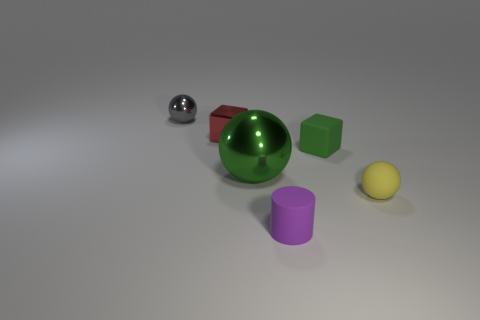Is there a tiny cube made of the same material as the large sphere?
Your answer should be compact. Yes. The block that is behind the matte thing behind the big green ball is made of what material?
Your answer should be compact. Metal. Are there an equal number of big green metal balls that are on the left side of the green metallic ball and green rubber cubes on the right side of the small yellow rubber ball?
Your answer should be very brief. Yes. Is the shape of the large metal object the same as the yellow object?
Give a very brief answer. Yes. There is a tiny thing that is left of the small green matte block and in front of the big green shiny sphere; what is its material?
Offer a very short reply. Rubber. What number of other small purple objects are the same shape as the small purple object?
Ensure brevity in your answer.  0. What is the size of the block that is right of the rubber thing in front of the small ball to the right of the matte cylinder?
Provide a short and direct response. Small. Are there more gray metal spheres that are on the right side of the green ball than tiny green rubber objects?
Offer a terse response. No. Are any blue objects visible?
Give a very brief answer. No. How many blue metal cubes are the same size as the green matte block?
Ensure brevity in your answer.  0. 